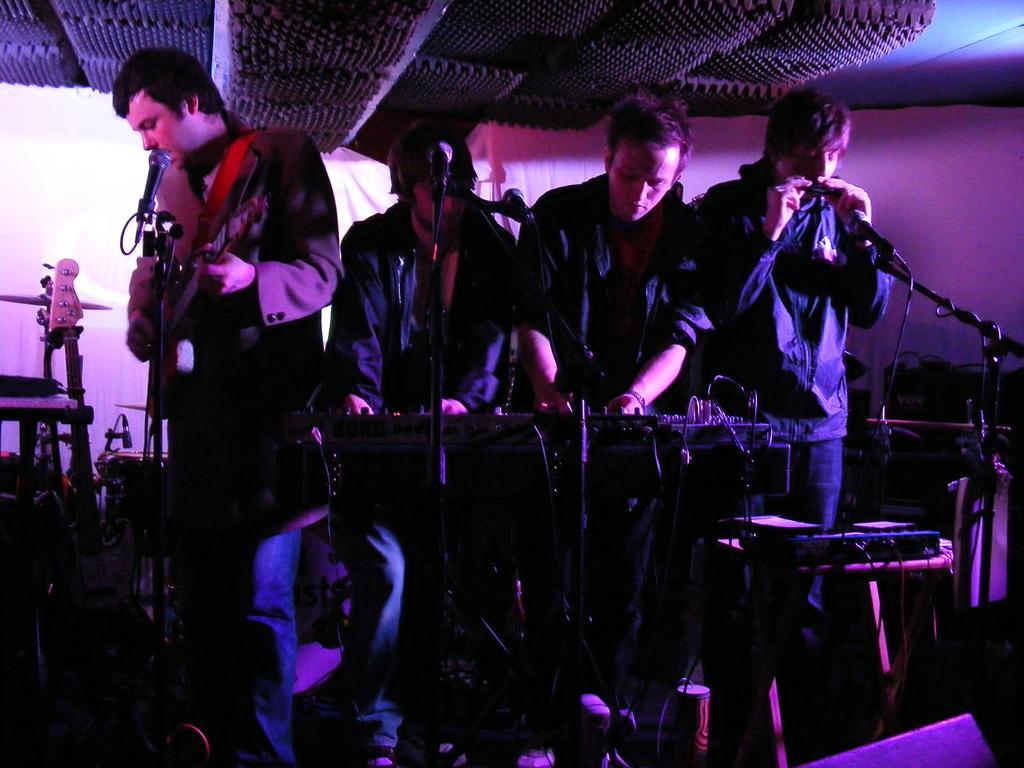Can you describe this image briefly? This image is clicked in a musical concert. There are four people on the stage and there are musical instruments in their hands. The one who is on the right side is singing something. Where are my eyes in front of them. There is a keyboard in the middle. The one who is on the left side is playing guitar and there are musical instruments on the left side. 